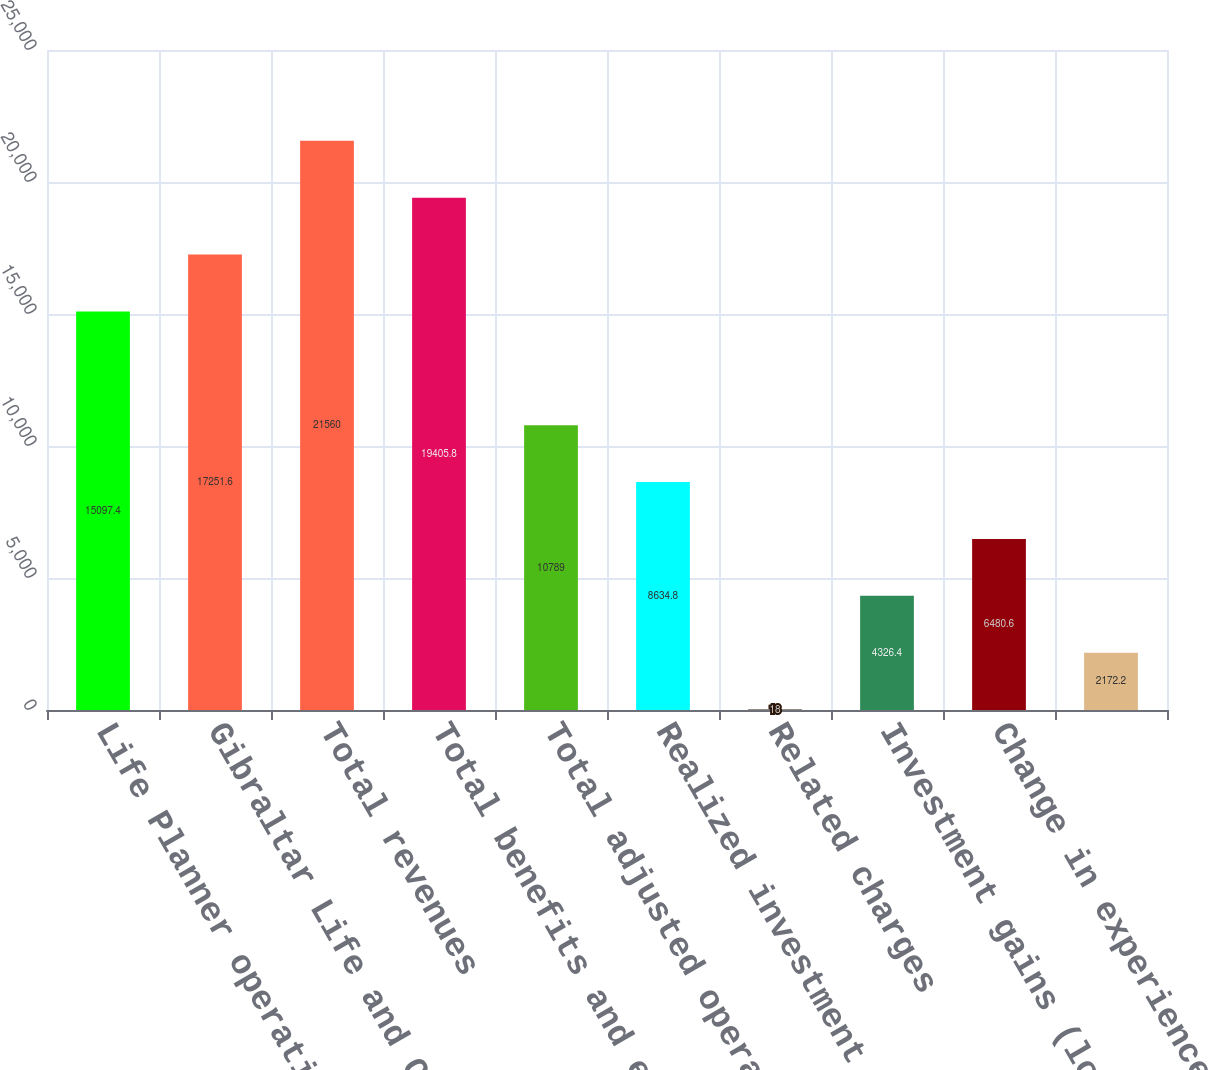Convert chart to OTSL. <chart><loc_0><loc_0><loc_500><loc_500><bar_chart><fcel>Life Planner operations<fcel>Gibraltar Life and Other<fcel>Total revenues<fcel>Total benefits and expenses<fcel>Total adjusted operating<fcel>Realized investment gains<fcel>Related charges<fcel>Investment gains (losses) on<fcel>Change in experience-rated<fcel>Unnamed: 9<nl><fcel>15097.4<fcel>17251.6<fcel>21560<fcel>19405.8<fcel>10789<fcel>8634.8<fcel>18<fcel>4326.4<fcel>6480.6<fcel>2172.2<nl></chart> 